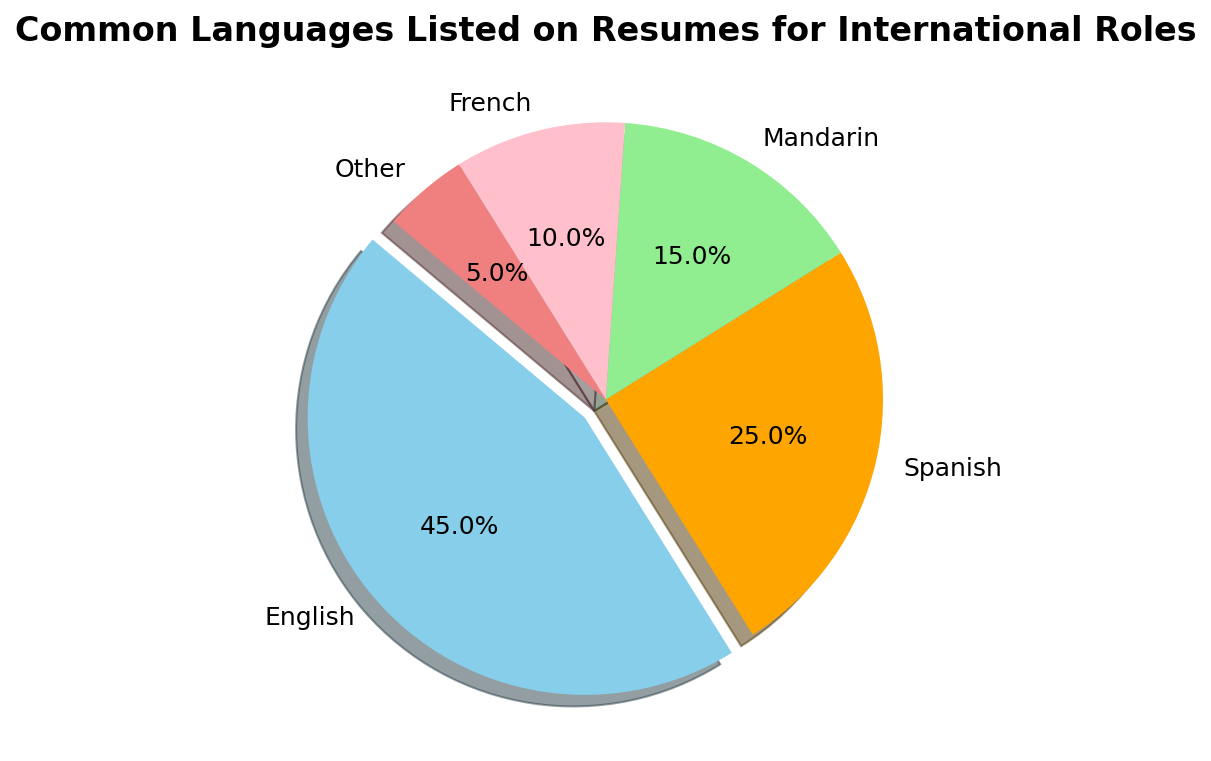What percentage of resumes list English as a common language? The pie chart highlights the section for English, which makes up 45%.
Answer: 45% Which language has the smallest representation in the pie chart, and what percentage does it have? The smallest section in the pie chart corresponds to "Other," making up 5%.
Answer: Other, 5% How much larger is the percentage of resumes listing Spanish compared to those listing French? Spanish occupies 25% of the pie chart, while French occupies 10%. The difference is 25% - 10% = 15%.
Answer: 15% What is the combined percentage of resumes listing Mandarin and French? Mandarin makes up 15% and French makes up 10%. The combined percentage is 15% + 10% = 25%.
Answer: 25% Rank the languages from most common to least common based on the pie chart. Based on the given percentages, the ranking from most common to least common is: English (45%), Spanish (25%), Mandarin (15%), French (10%), Other (5%).
Answer: English, Spanish, Mandarin, French, Other What is the proportion of resumes listing Spanish compared to Mandarin? Spanish has 25% and Mandarin has 15%. The ratio is 25% / 15%, resulting in 5/3 or approximately 1.67.
Answer: 1.67 How much larger is the sum of the percentages of English and Spanish compared to the sum of Mandarin, French, and Other? The sum of English (45%) and Spanish (25%) is 45% + 25% = 70%. The sum of Mandarin (15%), French (10%), and Other (5%) is 15% + 10% + 5% = 30%. The difference is 70% - 30% = 40%.
Answer: 40% Identify the language category in the pie chart represented by the pink color and provide its percentage. The pink color section corresponds to French, which has a percentage of 10%.
Answer: French, 10% If the total number of resumes is 200, how many of them list Mandarin as a common language? Mandarin makes up 15% of the resumes. To find the number of resumes listing Mandarin, calculate 15% of 200, which is 0.15 * 200 = 30.
Answer: 30 Which two languages together make up the largest segment in the pie chart and what is their combined percentage? The largest individual segment is English (45%), and the next largest is Spanish (25%). Together, they combine for 45% + 25% = 70%.
Answer: English and Spanish, 70% 